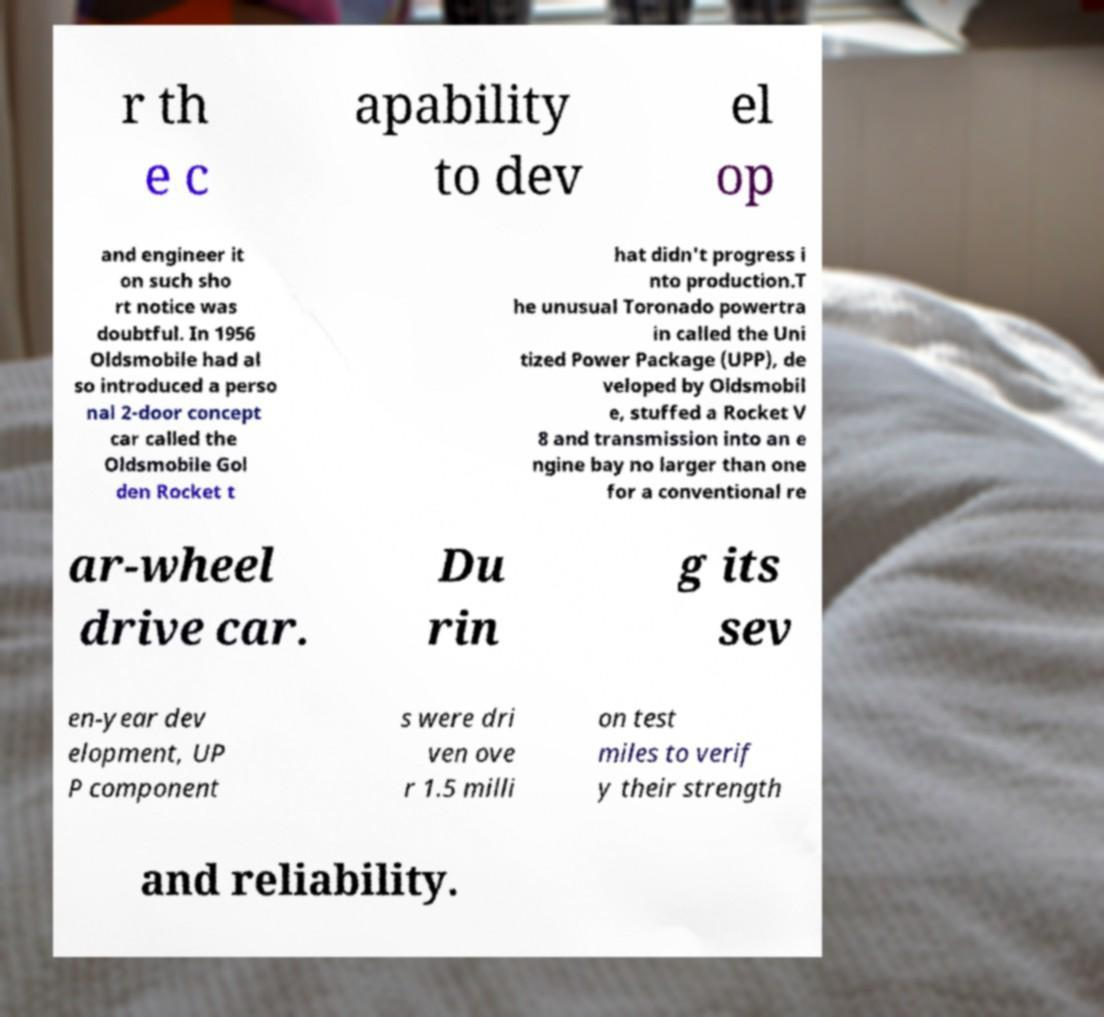Please identify and transcribe the text found in this image. r th e c apability to dev el op and engineer it on such sho rt notice was doubtful. In 1956 Oldsmobile had al so introduced a perso nal 2-door concept car called the Oldsmobile Gol den Rocket t hat didn't progress i nto production.T he unusual Toronado powertra in called the Uni tized Power Package (UPP), de veloped by Oldsmobil e, stuffed a Rocket V 8 and transmission into an e ngine bay no larger than one for a conventional re ar-wheel drive car. Du rin g its sev en-year dev elopment, UP P component s were dri ven ove r 1.5 milli on test miles to verif y their strength and reliability. 